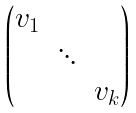Convert formula to latex. <formula><loc_0><loc_0><loc_500><loc_500>\begin{pmatrix} v _ { 1 } & & \\ & \ddots & \\ & & v _ { k } \end{pmatrix}</formula> 